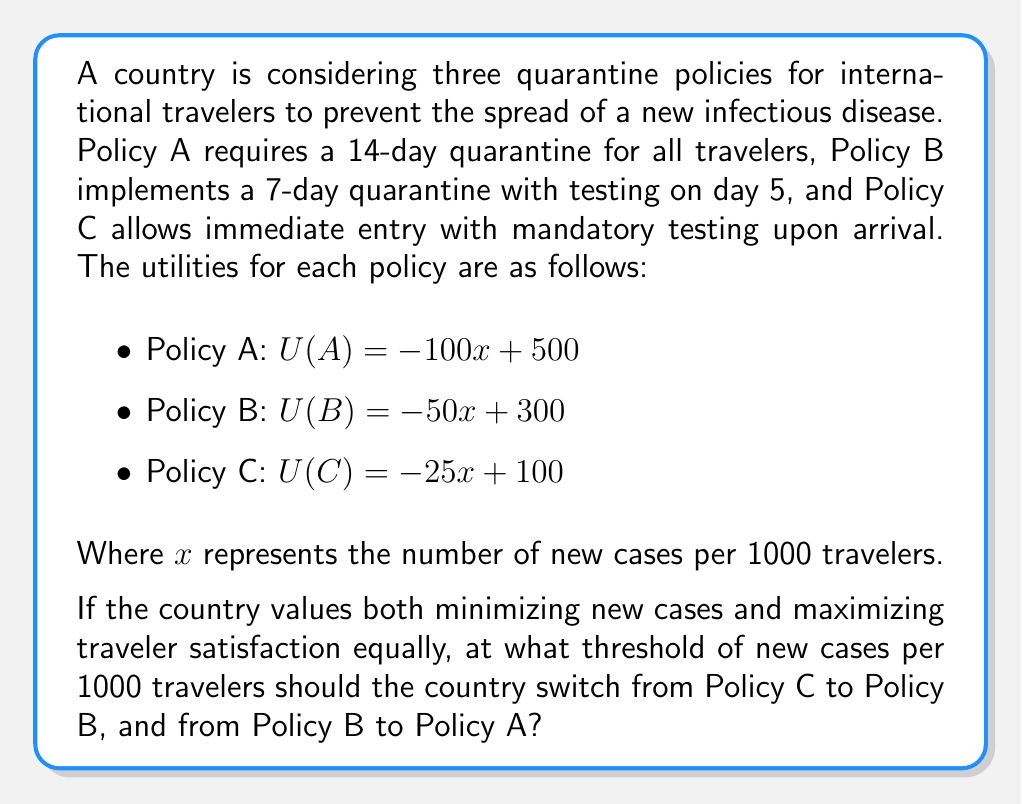Can you solve this math problem? To solve this problem, we need to use utility theory to compare the policies and find the points where one policy becomes more beneficial than another. We'll do this by finding the intersections of the utility functions.

1. First, let's find the intersection of Policy C and Policy B:
   $$-25x + 100 = -50x + 300$$
   $$25x = 200$$
   $$x = 8$$

   This means that when there are 8 new cases per 1000 travelers, Policy B becomes more beneficial than Policy C.

2. Now, let's find the intersection of Policy B and Policy A:
   $$-50x + 300 = -100x + 500$$
   $$50x = 200$$
   $$x = 4$$

   This means that when there are 4 new cases per 1000 travelers, Policy A becomes more beneficial than Policy B.

3. To verify, let's check the utility values at x = 4:
   U(A) = -100(4) + 500 = 100
   U(B) = -50(4) + 300 = 100
   U(C) = -25(4) + 100 = 0

   At x = 4, policies A and B have equal utility, while C has lower utility.

4. Similarly, at x = 8:
   U(A) = -100(8) + 500 = -300
   U(B) = -50(8) + 300 = -100
   U(C) = -25(8) + 100 = -100

   At x = 8, policies B and C have equal utility, while A has lower utility.

Therefore, the country should implement:
- Policy C when x < 8
- Policy B when 4 ≤ x < 8
- Policy A when x ≥ 4
Answer: The country should switch from Policy C to Policy B when there are 8 new cases per 1000 travelers, and from Policy B to Policy A when there are 4 new cases per 1000 travelers. 